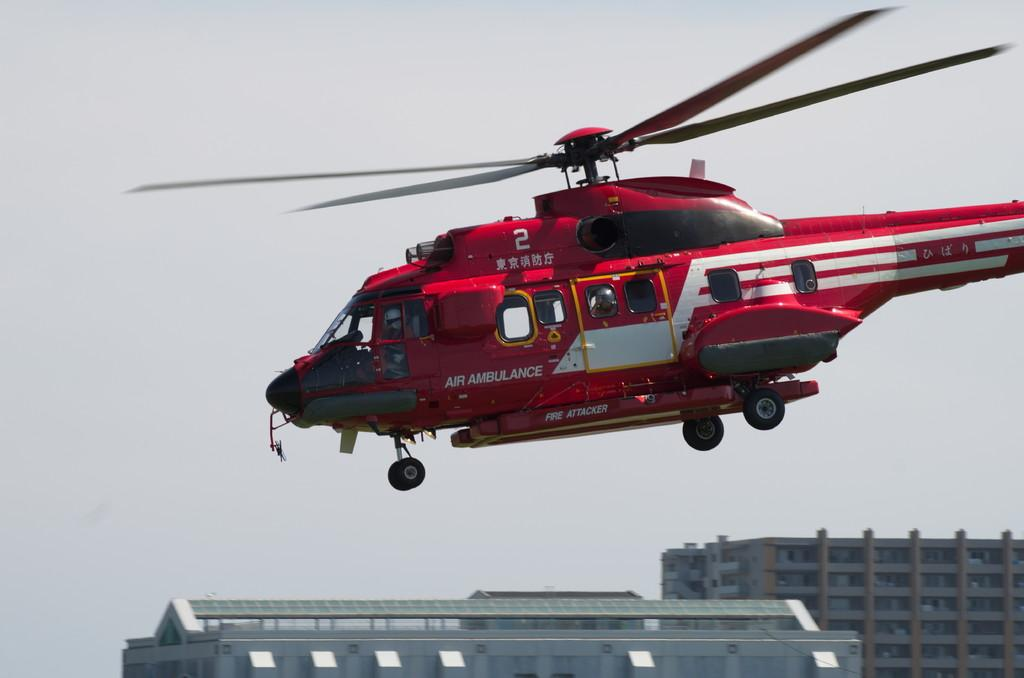What is the main subject of the image? The main subject of the image is a helicopter. In which direction is the helicopter flying? The helicopter is flying towards the left. What is the color of the helicopter? The helicopter is red in color. What can be seen at the bottom of the image? There are buildings at the bottom of the image. What is visible in the background of the image? The sky is visible in the background of the image. What type of umbrella is being used by the helicopter in the image? There is no umbrella present in the image; it features a red helicopter flying towards the left. How many plastic items can be seen in the image? There is no plastic item mentioned in the provided facts, so it cannot be determined from the image. 